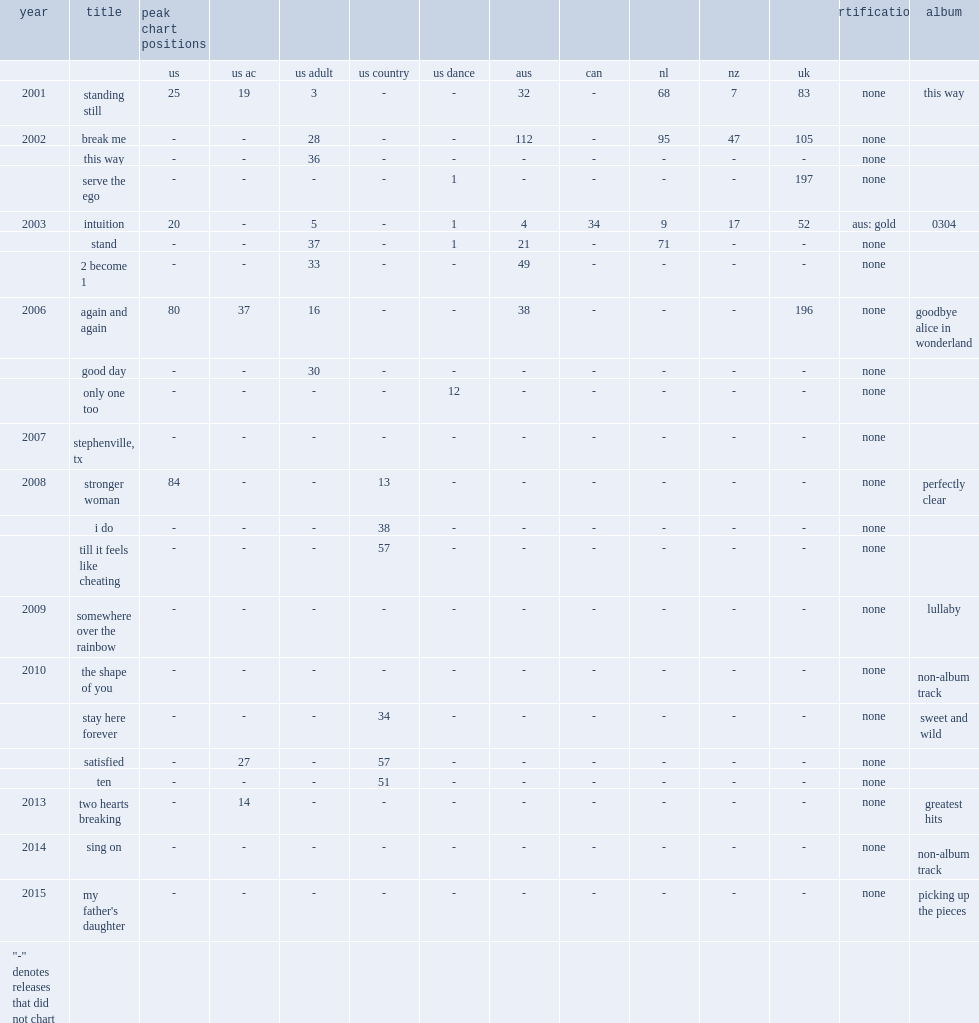When did the single"standing still" release? 2001.0. 